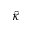Convert formula to latex. <formula><loc_0><loc_0><loc_500><loc_500>\hat { \kappa }</formula> 